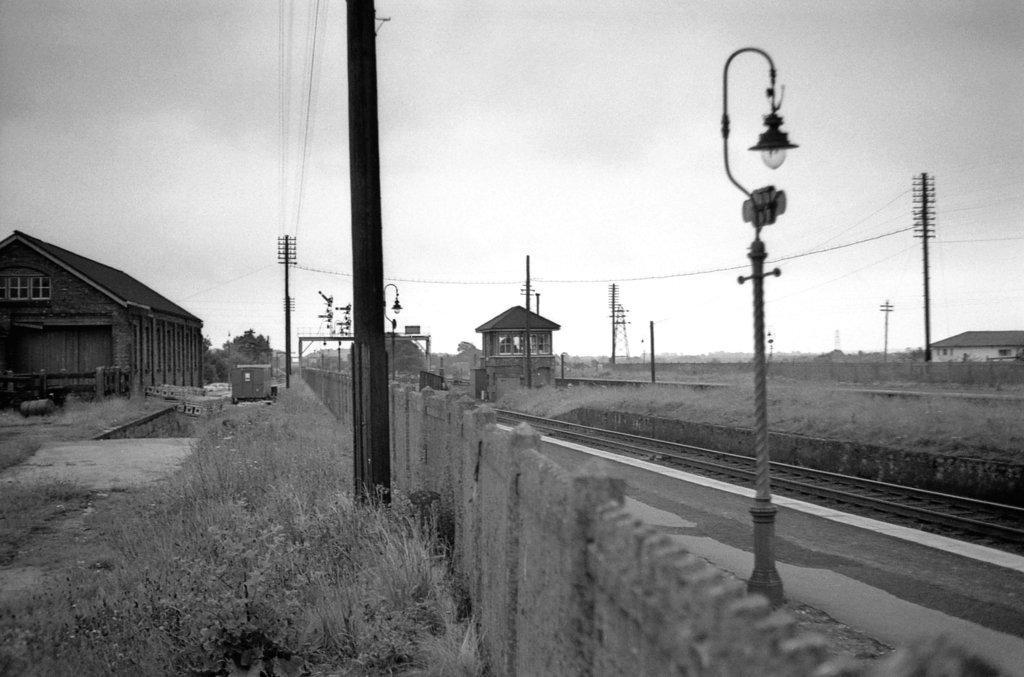Could you give a brief overview of what you see in this image? This is a black and white picture. I can see a railway track, there is a platform, there are poles, lights, cables, a cell tower, there is fence, plants, these are looking like sheds, this is looking like a vehicle, there are trees, and in the background there is sky. 